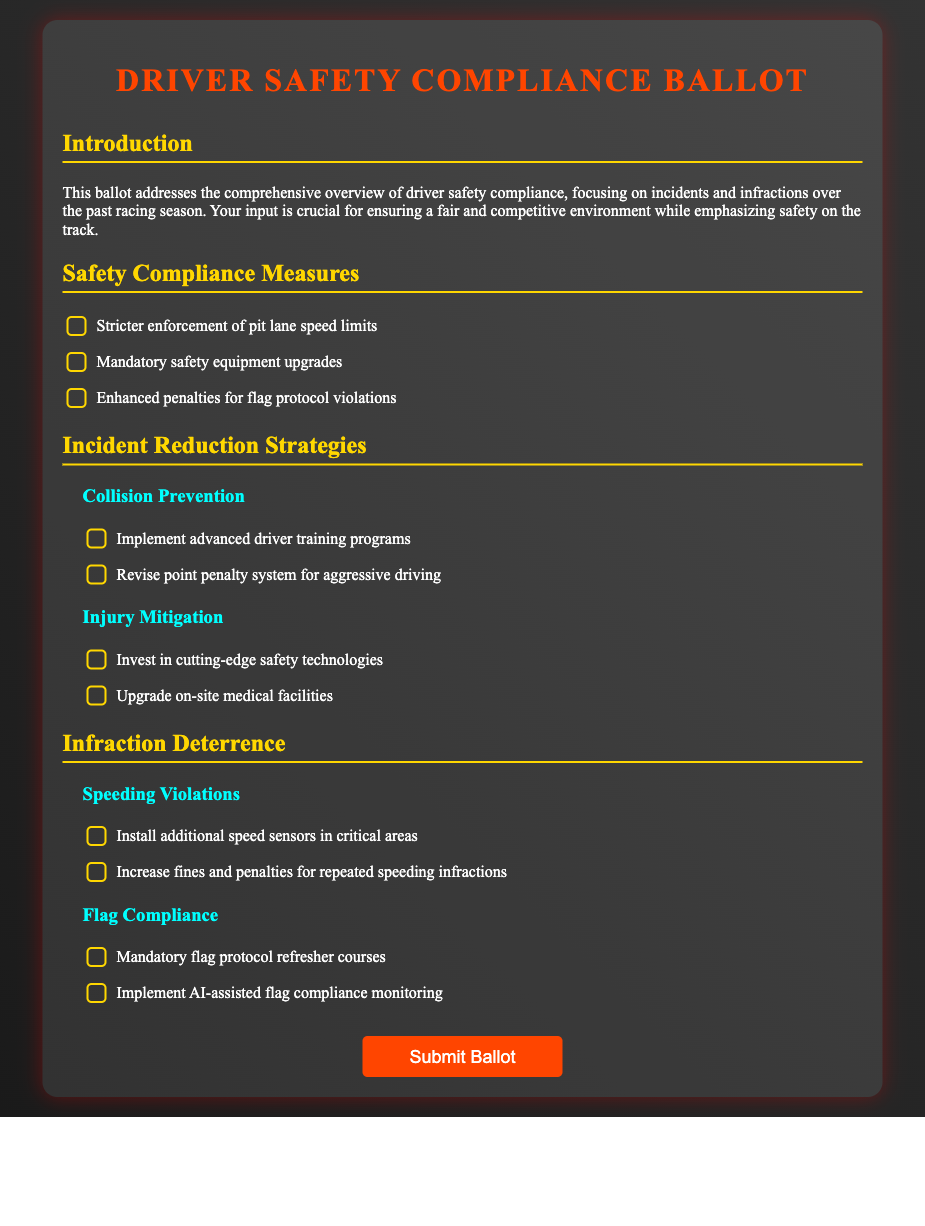What is the title of the document? The title is stated in the <title> tag of the HTML document.
Answer: Driver Safety Compliance Ballot How many sections are in the document? The document contains multiple sections, including "Introduction," "Safety Compliance Measures," "Incident Reduction Strategies," and "Infraction Deterrence."
Answer: 4 What is one measure suggested for speeding violations? The document lists recommended safety compliance measures, including actions related to speeding violations.
Answer: Increase fines and penalties for repeated speeding infractions Which strategy is related to injury mitigation? The document includes strategies focused on preventing injuries in racing events.
Answer: Upgrade on-site medical facilities What is the purpose of the ballot? The intention behind the ballot is mentioned in the introduction and relates to safety compliance on the racing track.
Answer: Ensuring a fair and competitive environment while emphasizing safety on the track How many safety compliance measures are listed? The total number of measures listed is specified within the "Safety Compliance Measures" section.
Answer: 3 What color theme is used in the document? The styling choices in the document are evident in the specified background and text colors.
Answer: Dark and bold colors Is there a checkbox for mandatory safety equipment upgrades? The section lists various safety measures, and checkboxes indicate options available for selection.
Answer: Yes 